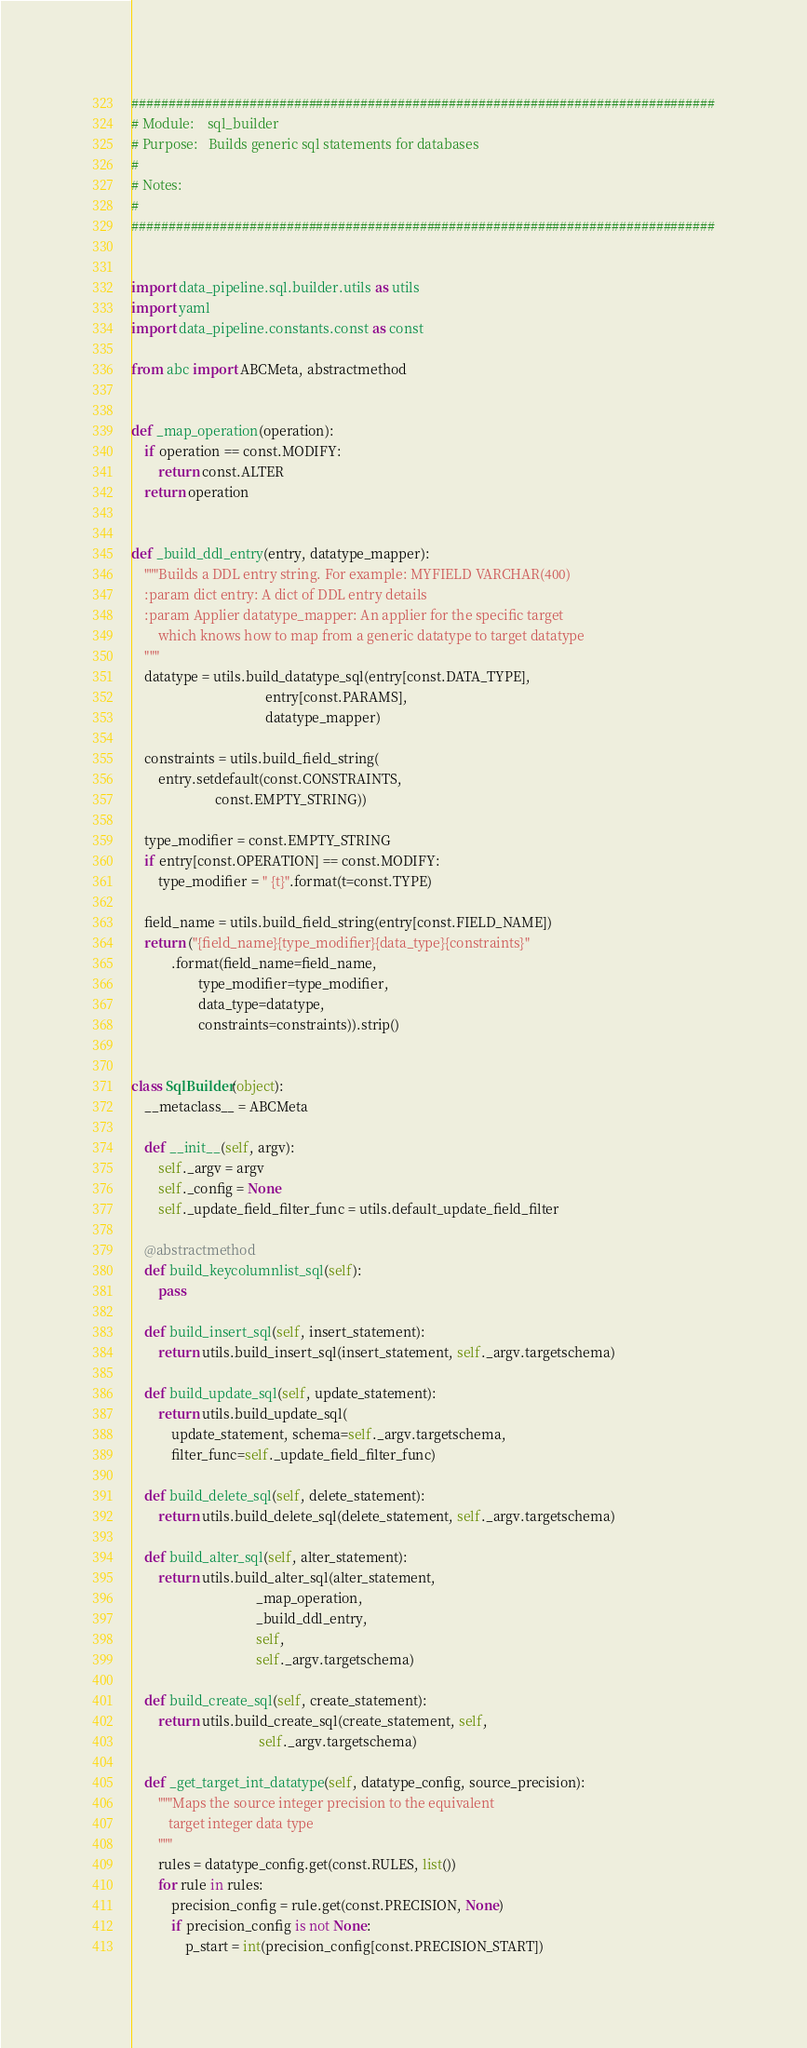<code> <loc_0><loc_0><loc_500><loc_500><_Python_>###############################################################################
# Module:    sql_builder
# Purpose:   Builds generic sql statements for databases
#
# Notes:
#
###############################################################################


import data_pipeline.sql.builder.utils as utils
import yaml
import data_pipeline.constants.const as const

from abc import ABCMeta, abstractmethod


def _map_operation(operation):
    if operation == const.MODIFY:
        return const.ALTER
    return operation


def _build_ddl_entry(entry, datatype_mapper):
    """Builds a DDL entry string. For example: MYFIELD VARCHAR(400)
    :param dict entry: A dict of DDL entry details
    :param Applier datatype_mapper: An applier for the specific target
        which knows how to map from a generic datatype to target datatype
    """
    datatype = utils.build_datatype_sql(entry[const.DATA_TYPE],
                                        entry[const.PARAMS],
                                        datatype_mapper)

    constraints = utils.build_field_string(
        entry.setdefault(const.CONSTRAINTS,
                         const.EMPTY_STRING))

    type_modifier = const.EMPTY_STRING
    if entry[const.OPERATION] == const.MODIFY:
        type_modifier = " {t}".format(t=const.TYPE)

    field_name = utils.build_field_string(entry[const.FIELD_NAME])
    return ("{field_name}{type_modifier}{data_type}{constraints}"
            .format(field_name=field_name,
                    type_modifier=type_modifier,
                    data_type=datatype,
                    constraints=constraints)).strip()


class SqlBuilder(object):
    __metaclass__ = ABCMeta

    def __init__(self, argv):
        self._argv = argv
        self._config = None
        self._update_field_filter_func = utils.default_update_field_filter

    @abstractmethod
    def build_keycolumnlist_sql(self):
        pass

    def build_insert_sql(self, insert_statement):
        return utils.build_insert_sql(insert_statement, self._argv.targetschema)

    def build_update_sql(self, update_statement):
        return utils.build_update_sql(
            update_statement, schema=self._argv.targetschema,
            filter_func=self._update_field_filter_func)

    def build_delete_sql(self, delete_statement):
        return utils.build_delete_sql(delete_statement, self._argv.targetschema)

    def build_alter_sql(self, alter_statement):
        return utils.build_alter_sql(alter_statement,
                                     _map_operation,
                                     _build_ddl_entry,
                                     self,
                                     self._argv.targetschema)

    def build_create_sql(self, create_statement):
        return utils.build_create_sql(create_statement, self,
                                      self._argv.targetschema)

    def _get_target_int_datatype(self, datatype_config, source_precision):
        """Maps the source integer precision to the equivalent
           target integer data type
        """
        rules = datatype_config.get(const.RULES, list())
        for rule in rules:
            precision_config = rule.get(const.PRECISION, None)
            if precision_config is not None:
                p_start = int(precision_config[const.PRECISION_START])</code> 